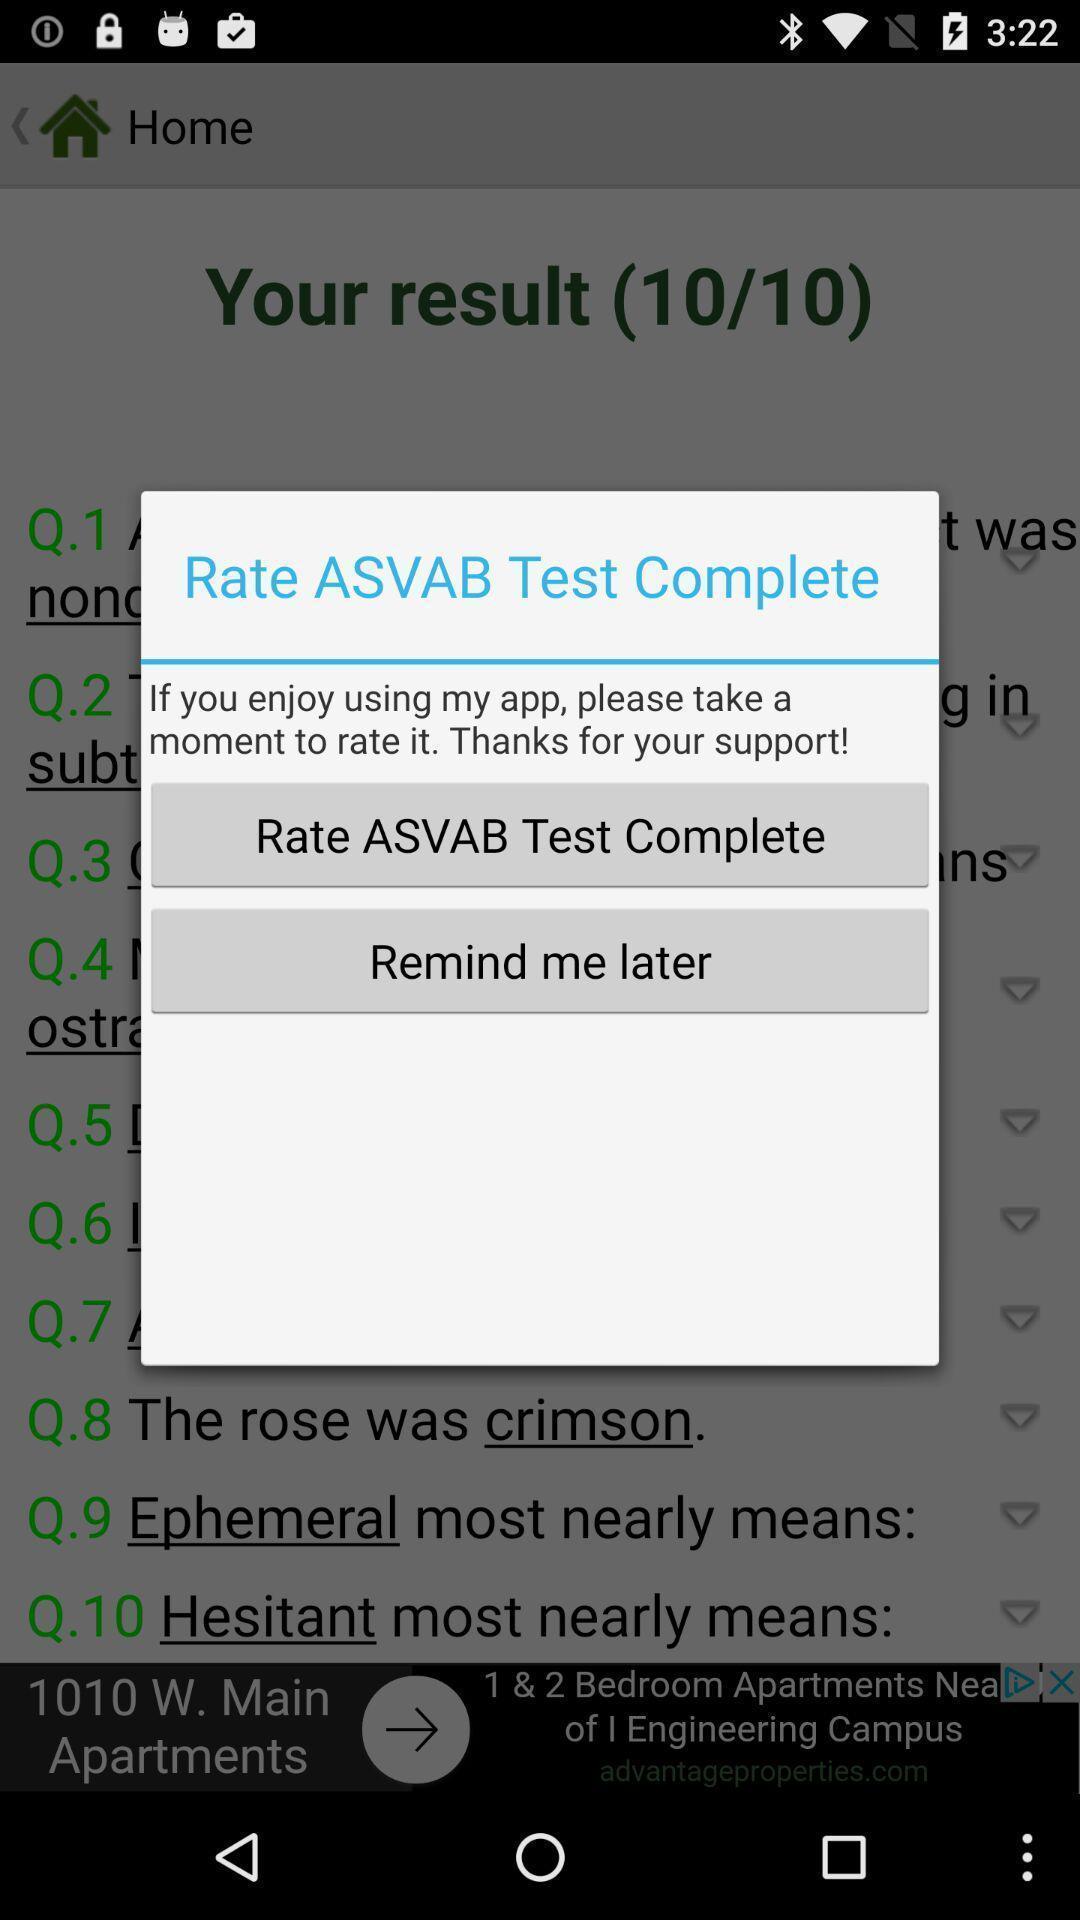Describe the visual elements of this screenshot. Popup notification for rating an app. 